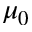<formula> <loc_0><loc_0><loc_500><loc_500>\mu _ { 0 }</formula> 